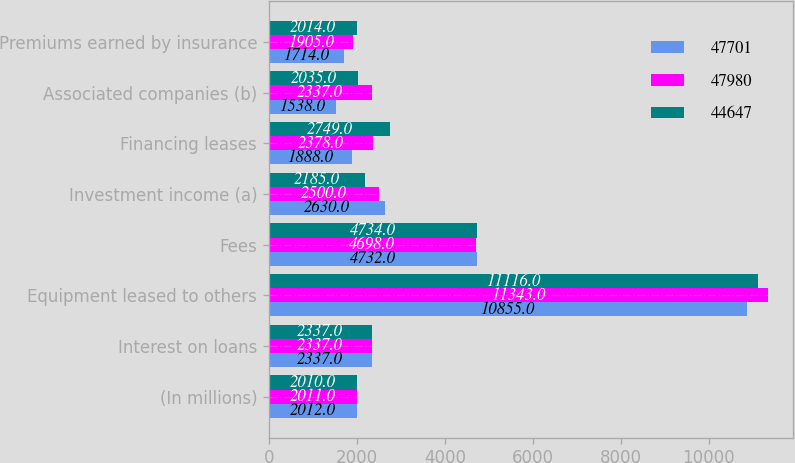<chart> <loc_0><loc_0><loc_500><loc_500><stacked_bar_chart><ecel><fcel>(In millions)<fcel>Interest on loans<fcel>Equipment leased to others<fcel>Fees<fcel>Investment income (a)<fcel>Financing leases<fcel>Associated companies (b)<fcel>Premiums earned by insurance<nl><fcel>47701<fcel>2012<fcel>2337<fcel>10855<fcel>4732<fcel>2630<fcel>1888<fcel>1538<fcel>1714<nl><fcel>47980<fcel>2011<fcel>2337<fcel>11343<fcel>4698<fcel>2500<fcel>2378<fcel>2337<fcel>1905<nl><fcel>44647<fcel>2010<fcel>2337<fcel>11116<fcel>4734<fcel>2185<fcel>2749<fcel>2035<fcel>2014<nl></chart> 